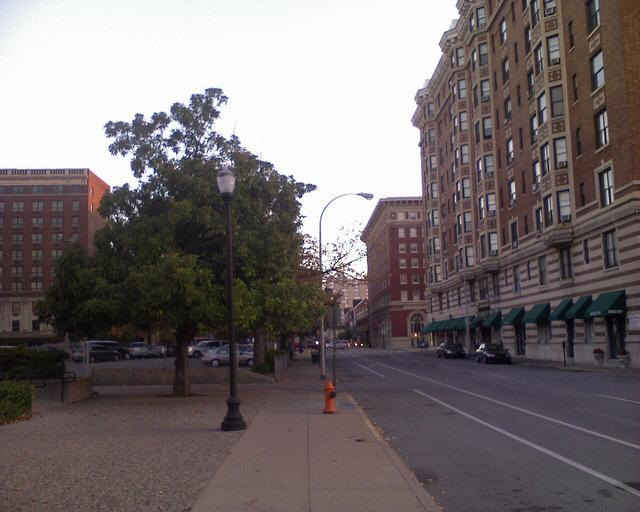During which season are the cars on this street parked? fall 